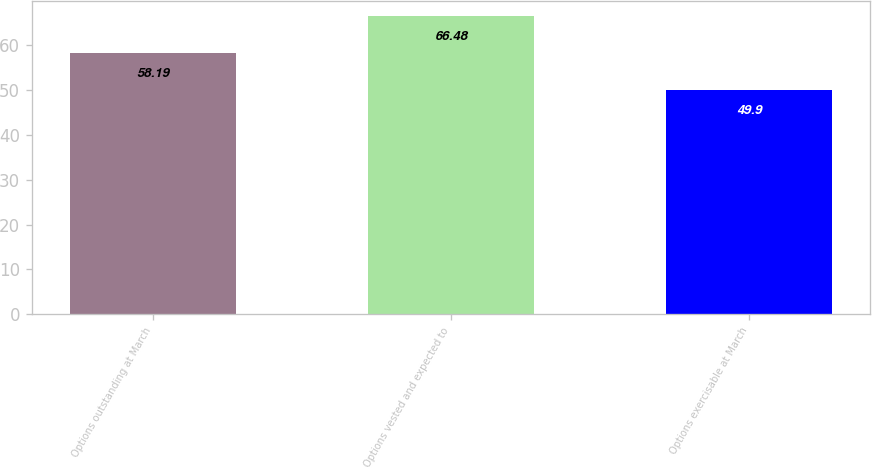Convert chart. <chart><loc_0><loc_0><loc_500><loc_500><bar_chart><fcel>Options outstanding at March<fcel>Options vested and expected to<fcel>Options exercisable at March<nl><fcel>58.19<fcel>66.48<fcel>49.9<nl></chart> 